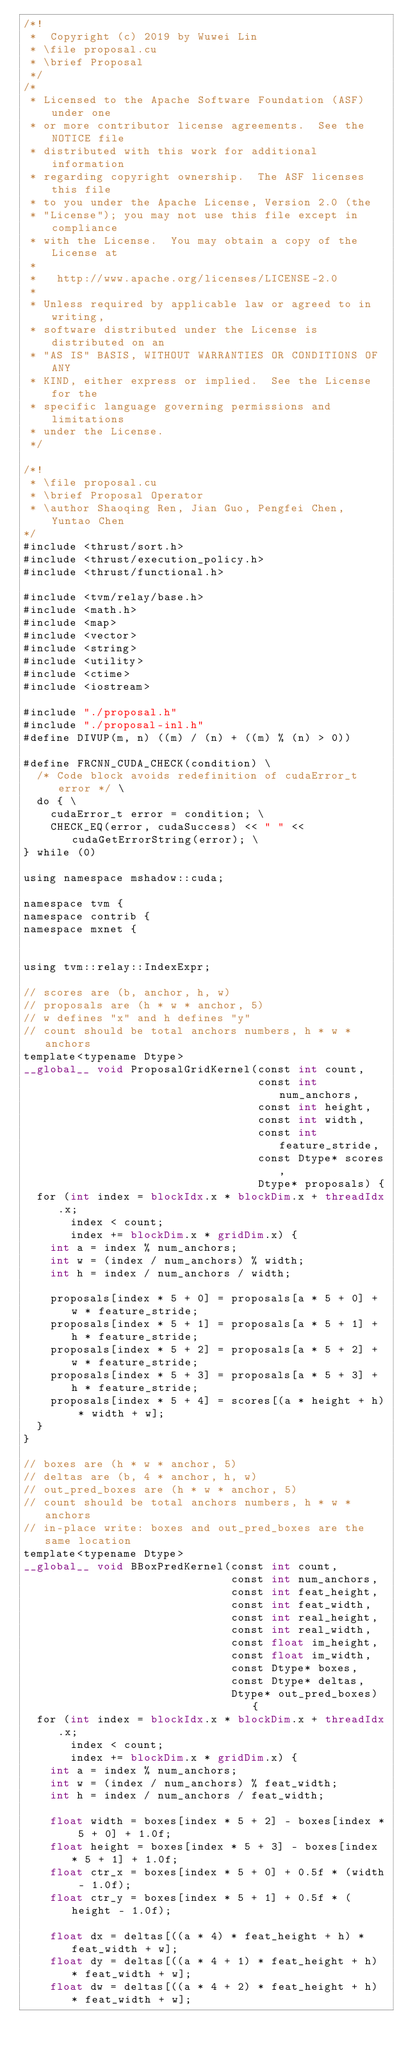<code> <loc_0><loc_0><loc_500><loc_500><_Cuda_>/*!
 *  Copyright (c) 2019 by Wuwei Lin
 * \file proposal.cu
 * \brief Proposal
 */
/*
 * Licensed to the Apache Software Foundation (ASF) under one
 * or more contributor license agreements.  See the NOTICE file
 * distributed with this work for additional information
 * regarding copyright ownership.  The ASF licenses this file
 * to you under the Apache License, Version 2.0 (the
 * "License"); you may not use this file except in compliance
 * with the License.  You may obtain a copy of the License at
 *
 *   http://www.apache.org/licenses/LICENSE-2.0
 *
 * Unless required by applicable law or agreed to in writing,
 * software distributed under the License is distributed on an
 * "AS IS" BASIS, WITHOUT WARRANTIES OR CONDITIONS OF ANY
 * KIND, either express or implied.  See the License for the
 * specific language governing permissions and limitations
 * under the License.
 */

/*!
 * \file proposal.cu
 * \brief Proposal Operator
 * \author Shaoqing Ren, Jian Guo, Pengfei Chen, Yuntao Chen
*/
#include <thrust/sort.h>
#include <thrust/execution_policy.h>
#include <thrust/functional.h>

#include <tvm/relay/base.h>
#include <math.h>
#include <map>
#include <vector>
#include <string>
#include <utility>
#include <ctime>
#include <iostream>

#include "./proposal.h"
#include "./proposal-inl.h"
#define DIVUP(m, n) ((m) / (n) + ((m) % (n) > 0))

#define FRCNN_CUDA_CHECK(condition) \
  /* Code block avoids redefinition of cudaError_t error */ \
  do { \
    cudaError_t error = condition; \
    CHECK_EQ(error, cudaSuccess) << " " << cudaGetErrorString(error); \
} while (0)

using namespace mshadow::cuda;

namespace tvm {
namespace contrib {
namespace mxnet {


using tvm::relay::IndexExpr;

// scores are (b, anchor, h, w)
// proposals are (h * w * anchor, 5)
// w defines "x" and h defines "y"
// count should be total anchors numbers, h * w * anchors
template<typename Dtype>
__global__ void ProposalGridKernel(const int count,
                                   const int num_anchors,
                                   const int height,
                                   const int width,
                                   const int feature_stride,
                                   const Dtype* scores,
                                   Dtype* proposals) {
  for (int index = blockIdx.x * blockDim.x + threadIdx.x;
       index < count;
       index += blockDim.x * gridDim.x) {
    int a = index % num_anchors;
    int w = (index / num_anchors) % width;
    int h = index / num_anchors / width;

    proposals[index * 5 + 0] = proposals[a * 5 + 0] + w * feature_stride;
    proposals[index * 5 + 1] = proposals[a * 5 + 1] + h * feature_stride;
    proposals[index * 5 + 2] = proposals[a * 5 + 2] + w * feature_stride;
    proposals[index * 5 + 3] = proposals[a * 5 + 3] + h * feature_stride;
    proposals[index * 5 + 4] = scores[(a * height + h) * width + w];
  }
}

// boxes are (h * w * anchor, 5)
// deltas are (b, 4 * anchor, h, w)
// out_pred_boxes are (h * w * anchor, 5)
// count should be total anchors numbers, h * w * anchors
// in-place write: boxes and out_pred_boxes are the same location
template<typename Dtype>
__global__ void BBoxPredKernel(const int count,
                               const int num_anchors,
                               const int feat_height,
                               const int feat_width,
                               const int real_height,
                               const int real_width,
                               const float im_height,
                               const float im_width,
                               const Dtype* boxes,
                               const Dtype* deltas,
                               Dtype* out_pred_boxes) {
  for (int index = blockIdx.x * blockDim.x + threadIdx.x;
       index < count;
       index += blockDim.x * gridDim.x) {
    int a = index % num_anchors;
    int w = (index / num_anchors) % feat_width;
    int h = index / num_anchors / feat_width;

    float width = boxes[index * 5 + 2] - boxes[index * 5 + 0] + 1.0f;
    float height = boxes[index * 5 + 3] - boxes[index * 5 + 1] + 1.0f;
    float ctr_x = boxes[index * 5 + 0] + 0.5f * (width - 1.0f);
    float ctr_y = boxes[index * 5 + 1] + 0.5f * (height - 1.0f);

    float dx = deltas[((a * 4) * feat_height + h) * feat_width + w];
    float dy = deltas[((a * 4 + 1) * feat_height + h) * feat_width + w];
    float dw = deltas[((a * 4 + 2) * feat_height + h) * feat_width + w];</code> 